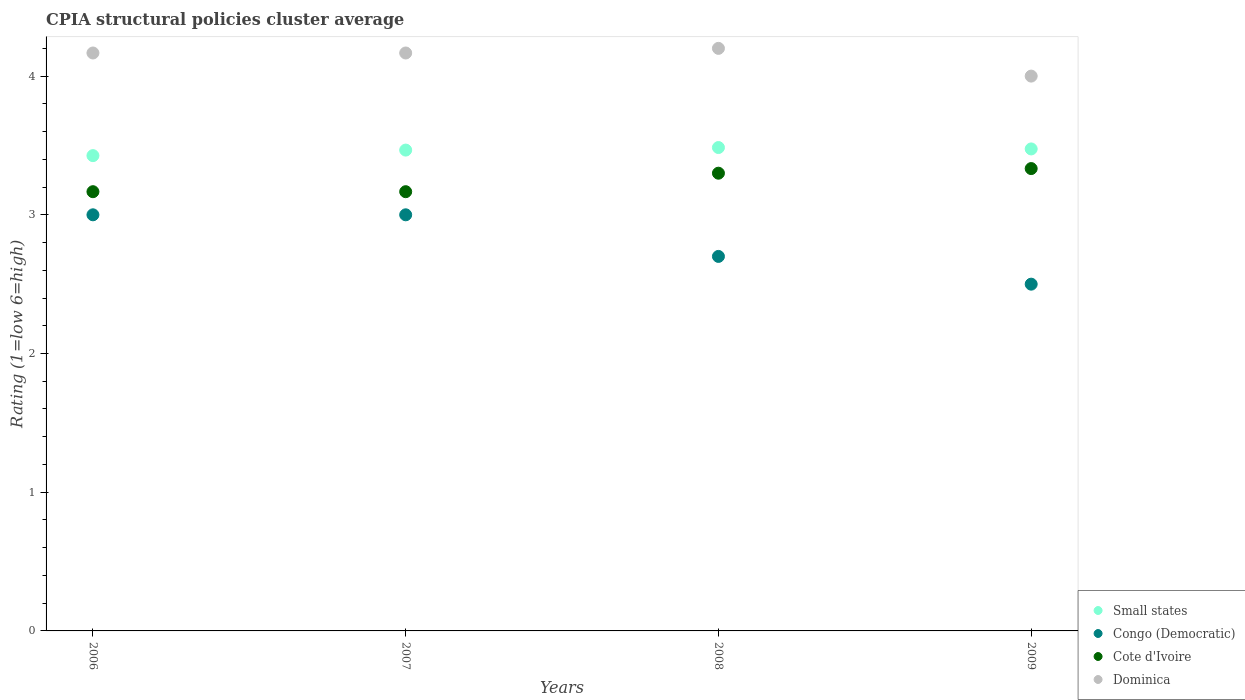How many different coloured dotlines are there?
Provide a succinct answer. 4. What is the CPIA rating in Small states in 2008?
Offer a terse response. 3.48. In which year was the CPIA rating in Dominica maximum?
Provide a short and direct response. 2008. In which year was the CPIA rating in Congo (Democratic) minimum?
Keep it short and to the point. 2009. What is the difference between the CPIA rating in Small states in 2006 and the CPIA rating in Dominica in 2008?
Provide a succinct answer. -0.77. What is the average CPIA rating in Small states per year?
Ensure brevity in your answer.  3.46. In the year 2006, what is the difference between the CPIA rating in Cote d'Ivoire and CPIA rating in Small states?
Keep it short and to the point. -0.26. What is the difference between the highest and the second highest CPIA rating in Congo (Democratic)?
Your answer should be very brief. 0. What is the difference between the highest and the lowest CPIA rating in Dominica?
Your response must be concise. 0.2. Is the sum of the CPIA rating in Cote d'Ivoire in 2006 and 2009 greater than the maximum CPIA rating in Congo (Democratic) across all years?
Provide a short and direct response. Yes. Is it the case that in every year, the sum of the CPIA rating in Small states and CPIA rating in Cote d'Ivoire  is greater than the sum of CPIA rating in Dominica and CPIA rating in Congo (Democratic)?
Your answer should be very brief. No. Is it the case that in every year, the sum of the CPIA rating in Congo (Democratic) and CPIA rating in Small states  is greater than the CPIA rating in Dominica?
Provide a succinct answer. Yes. Does the CPIA rating in Cote d'Ivoire monotonically increase over the years?
Provide a short and direct response. No. Is the CPIA rating in Congo (Democratic) strictly greater than the CPIA rating in Small states over the years?
Offer a terse response. No. Are the values on the major ticks of Y-axis written in scientific E-notation?
Make the answer very short. No. Does the graph contain any zero values?
Your answer should be very brief. No. How many legend labels are there?
Your answer should be very brief. 4. What is the title of the graph?
Offer a terse response. CPIA structural policies cluster average. Does "Hungary" appear as one of the legend labels in the graph?
Make the answer very short. No. What is the label or title of the Y-axis?
Provide a short and direct response. Rating (1=low 6=high). What is the Rating (1=low 6=high) of Small states in 2006?
Provide a short and direct response. 3.43. What is the Rating (1=low 6=high) of Cote d'Ivoire in 2006?
Your answer should be compact. 3.17. What is the Rating (1=low 6=high) in Dominica in 2006?
Offer a very short reply. 4.17. What is the Rating (1=low 6=high) of Small states in 2007?
Your answer should be very brief. 3.47. What is the Rating (1=low 6=high) of Cote d'Ivoire in 2007?
Provide a short and direct response. 3.17. What is the Rating (1=low 6=high) of Dominica in 2007?
Give a very brief answer. 4.17. What is the Rating (1=low 6=high) in Small states in 2008?
Make the answer very short. 3.48. What is the Rating (1=low 6=high) in Cote d'Ivoire in 2008?
Your response must be concise. 3.3. What is the Rating (1=low 6=high) of Small states in 2009?
Provide a short and direct response. 3.48. What is the Rating (1=low 6=high) of Cote d'Ivoire in 2009?
Your answer should be compact. 3.33. What is the Rating (1=low 6=high) of Dominica in 2009?
Ensure brevity in your answer.  4. Across all years, what is the maximum Rating (1=low 6=high) in Small states?
Keep it short and to the point. 3.48. Across all years, what is the maximum Rating (1=low 6=high) of Cote d'Ivoire?
Give a very brief answer. 3.33. Across all years, what is the minimum Rating (1=low 6=high) of Small states?
Give a very brief answer. 3.43. Across all years, what is the minimum Rating (1=low 6=high) in Cote d'Ivoire?
Offer a terse response. 3.17. What is the total Rating (1=low 6=high) of Small states in the graph?
Provide a succinct answer. 13.85. What is the total Rating (1=low 6=high) of Congo (Democratic) in the graph?
Offer a very short reply. 11.2. What is the total Rating (1=low 6=high) of Cote d'Ivoire in the graph?
Keep it short and to the point. 12.97. What is the total Rating (1=low 6=high) in Dominica in the graph?
Provide a succinct answer. 16.53. What is the difference between the Rating (1=low 6=high) in Small states in 2006 and that in 2007?
Your answer should be compact. -0.04. What is the difference between the Rating (1=low 6=high) in Cote d'Ivoire in 2006 and that in 2007?
Your answer should be compact. 0. What is the difference between the Rating (1=low 6=high) of Dominica in 2006 and that in 2007?
Your answer should be compact. 0. What is the difference between the Rating (1=low 6=high) in Small states in 2006 and that in 2008?
Offer a very short reply. -0.06. What is the difference between the Rating (1=low 6=high) in Congo (Democratic) in 2006 and that in 2008?
Your response must be concise. 0.3. What is the difference between the Rating (1=low 6=high) of Cote d'Ivoire in 2006 and that in 2008?
Ensure brevity in your answer.  -0.13. What is the difference between the Rating (1=low 6=high) of Dominica in 2006 and that in 2008?
Offer a very short reply. -0.03. What is the difference between the Rating (1=low 6=high) in Small states in 2006 and that in 2009?
Your answer should be very brief. -0.05. What is the difference between the Rating (1=low 6=high) of Small states in 2007 and that in 2008?
Your answer should be very brief. -0.02. What is the difference between the Rating (1=low 6=high) of Congo (Democratic) in 2007 and that in 2008?
Make the answer very short. 0.3. What is the difference between the Rating (1=low 6=high) in Cote d'Ivoire in 2007 and that in 2008?
Offer a very short reply. -0.13. What is the difference between the Rating (1=low 6=high) of Dominica in 2007 and that in 2008?
Give a very brief answer. -0.03. What is the difference between the Rating (1=low 6=high) in Small states in 2007 and that in 2009?
Offer a terse response. -0.01. What is the difference between the Rating (1=low 6=high) in Congo (Democratic) in 2007 and that in 2009?
Your response must be concise. 0.5. What is the difference between the Rating (1=low 6=high) of Congo (Democratic) in 2008 and that in 2009?
Offer a terse response. 0.2. What is the difference between the Rating (1=low 6=high) of Cote d'Ivoire in 2008 and that in 2009?
Offer a very short reply. -0.03. What is the difference between the Rating (1=low 6=high) in Small states in 2006 and the Rating (1=low 6=high) in Congo (Democratic) in 2007?
Make the answer very short. 0.43. What is the difference between the Rating (1=low 6=high) in Small states in 2006 and the Rating (1=low 6=high) in Cote d'Ivoire in 2007?
Give a very brief answer. 0.26. What is the difference between the Rating (1=low 6=high) in Small states in 2006 and the Rating (1=low 6=high) in Dominica in 2007?
Offer a very short reply. -0.74. What is the difference between the Rating (1=low 6=high) of Congo (Democratic) in 2006 and the Rating (1=low 6=high) of Cote d'Ivoire in 2007?
Offer a very short reply. -0.17. What is the difference between the Rating (1=low 6=high) in Congo (Democratic) in 2006 and the Rating (1=low 6=high) in Dominica in 2007?
Offer a very short reply. -1.17. What is the difference between the Rating (1=low 6=high) of Cote d'Ivoire in 2006 and the Rating (1=low 6=high) of Dominica in 2007?
Offer a very short reply. -1. What is the difference between the Rating (1=low 6=high) of Small states in 2006 and the Rating (1=low 6=high) of Congo (Democratic) in 2008?
Your answer should be very brief. 0.73. What is the difference between the Rating (1=low 6=high) of Small states in 2006 and the Rating (1=low 6=high) of Cote d'Ivoire in 2008?
Give a very brief answer. 0.13. What is the difference between the Rating (1=low 6=high) in Small states in 2006 and the Rating (1=low 6=high) in Dominica in 2008?
Ensure brevity in your answer.  -0.77. What is the difference between the Rating (1=low 6=high) of Congo (Democratic) in 2006 and the Rating (1=low 6=high) of Dominica in 2008?
Your answer should be compact. -1.2. What is the difference between the Rating (1=low 6=high) of Cote d'Ivoire in 2006 and the Rating (1=low 6=high) of Dominica in 2008?
Your answer should be very brief. -1.03. What is the difference between the Rating (1=low 6=high) in Small states in 2006 and the Rating (1=low 6=high) in Congo (Democratic) in 2009?
Your answer should be very brief. 0.93. What is the difference between the Rating (1=low 6=high) of Small states in 2006 and the Rating (1=low 6=high) of Cote d'Ivoire in 2009?
Give a very brief answer. 0.09. What is the difference between the Rating (1=low 6=high) of Small states in 2006 and the Rating (1=low 6=high) of Dominica in 2009?
Keep it short and to the point. -0.57. What is the difference between the Rating (1=low 6=high) of Congo (Democratic) in 2006 and the Rating (1=low 6=high) of Dominica in 2009?
Provide a short and direct response. -1. What is the difference between the Rating (1=low 6=high) in Small states in 2007 and the Rating (1=low 6=high) in Congo (Democratic) in 2008?
Make the answer very short. 0.77. What is the difference between the Rating (1=low 6=high) of Small states in 2007 and the Rating (1=low 6=high) of Cote d'Ivoire in 2008?
Provide a succinct answer. 0.17. What is the difference between the Rating (1=low 6=high) of Small states in 2007 and the Rating (1=low 6=high) of Dominica in 2008?
Make the answer very short. -0.73. What is the difference between the Rating (1=low 6=high) in Congo (Democratic) in 2007 and the Rating (1=low 6=high) in Cote d'Ivoire in 2008?
Keep it short and to the point. -0.3. What is the difference between the Rating (1=low 6=high) in Congo (Democratic) in 2007 and the Rating (1=low 6=high) in Dominica in 2008?
Give a very brief answer. -1.2. What is the difference between the Rating (1=low 6=high) in Cote d'Ivoire in 2007 and the Rating (1=low 6=high) in Dominica in 2008?
Keep it short and to the point. -1.03. What is the difference between the Rating (1=low 6=high) of Small states in 2007 and the Rating (1=low 6=high) of Congo (Democratic) in 2009?
Offer a terse response. 0.97. What is the difference between the Rating (1=low 6=high) of Small states in 2007 and the Rating (1=low 6=high) of Cote d'Ivoire in 2009?
Keep it short and to the point. 0.13. What is the difference between the Rating (1=low 6=high) of Small states in 2007 and the Rating (1=low 6=high) of Dominica in 2009?
Give a very brief answer. -0.53. What is the difference between the Rating (1=low 6=high) of Small states in 2008 and the Rating (1=low 6=high) of Cote d'Ivoire in 2009?
Your answer should be compact. 0.15. What is the difference between the Rating (1=low 6=high) in Small states in 2008 and the Rating (1=low 6=high) in Dominica in 2009?
Your answer should be very brief. -0.52. What is the difference between the Rating (1=low 6=high) in Congo (Democratic) in 2008 and the Rating (1=low 6=high) in Cote d'Ivoire in 2009?
Keep it short and to the point. -0.63. What is the average Rating (1=low 6=high) of Small states per year?
Provide a succinct answer. 3.46. What is the average Rating (1=low 6=high) in Congo (Democratic) per year?
Your response must be concise. 2.8. What is the average Rating (1=low 6=high) of Cote d'Ivoire per year?
Make the answer very short. 3.24. What is the average Rating (1=low 6=high) in Dominica per year?
Offer a very short reply. 4.13. In the year 2006, what is the difference between the Rating (1=low 6=high) of Small states and Rating (1=low 6=high) of Congo (Democratic)?
Offer a terse response. 0.43. In the year 2006, what is the difference between the Rating (1=low 6=high) in Small states and Rating (1=low 6=high) in Cote d'Ivoire?
Provide a short and direct response. 0.26. In the year 2006, what is the difference between the Rating (1=low 6=high) in Small states and Rating (1=low 6=high) in Dominica?
Provide a short and direct response. -0.74. In the year 2006, what is the difference between the Rating (1=low 6=high) in Congo (Democratic) and Rating (1=low 6=high) in Dominica?
Give a very brief answer. -1.17. In the year 2006, what is the difference between the Rating (1=low 6=high) in Cote d'Ivoire and Rating (1=low 6=high) in Dominica?
Give a very brief answer. -1. In the year 2007, what is the difference between the Rating (1=low 6=high) in Small states and Rating (1=low 6=high) in Congo (Democratic)?
Make the answer very short. 0.47. In the year 2007, what is the difference between the Rating (1=low 6=high) in Small states and Rating (1=low 6=high) in Cote d'Ivoire?
Ensure brevity in your answer.  0.3. In the year 2007, what is the difference between the Rating (1=low 6=high) of Small states and Rating (1=low 6=high) of Dominica?
Keep it short and to the point. -0.7. In the year 2007, what is the difference between the Rating (1=low 6=high) in Congo (Democratic) and Rating (1=low 6=high) in Dominica?
Your answer should be very brief. -1.17. In the year 2008, what is the difference between the Rating (1=low 6=high) in Small states and Rating (1=low 6=high) in Congo (Democratic)?
Your answer should be compact. 0.79. In the year 2008, what is the difference between the Rating (1=low 6=high) in Small states and Rating (1=low 6=high) in Cote d'Ivoire?
Your answer should be very brief. 0.18. In the year 2008, what is the difference between the Rating (1=low 6=high) in Small states and Rating (1=low 6=high) in Dominica?
Your answer should be very brief. -0.71. In the year 2008, what is the difference between the Rating (1=low 6=high) in Congo (Democratic) and Rating (1=low 6=high) in Cote d'Ivoire?
Keep it short and to the point. -0.6. In the year 2008, what is the difference between the Rating (1=low 6=high) of Congo (Democratic) and Rating (1=low 6=high) of Dominica?
Give a very brief answer. -1.5. In the year 2009, what is the difference between the Rating (1=low 6=high) in Small states and Rating (1=low 6=high) in Cote d'Ivoire?
Your response must be concise. 0.14. In the year 2009, what is the difference between the Rating (1=low 6=high) of Small states and Rating (1=low 6=high) of Dominica?
Give a very brief answer. -0.53. What is the ratio of the Rating (1=low 6=high) of Small states in 2006 to that in 2008?
Ensure brevity in your answer.  0.98. What is the ratio of the Rating (1=low 6=high) of Cote d'Ivoire in 2006 to that in 2008?
Your response must be concise. 0.96. What is the ratio of the Rating (1=low 6=high) in Small states in 2006 to that in 2009?
Your answer should be very brief. 0.99. What is the ratio of the Rating (1=low 6=high) in Dominica in 2006 to that in 2009?
Offer a very short reply. 1.04. What is the ratio of the Rating (1=low 6=high) of Congo (Democratic) in 2007 to that in 2008?
Your response must be concise. 1.11. What is the ratio of the Rating (1=low 6=high) in Cote d'Ivoire in 2007 to that in 2008?
Offer a terse response. 0.96. What is the ratio of the Rating (1=low 6=high) of Dominica in 2007 to that in 2008?
Give a very brief answer. 0.99. What is the ratio of the Rating (1=low 6=high) in Small states in 2007 to that in 2009?
Provide a succinct answer. 1. What is the ratio of the Rating (1=low 6=high) in Cote d'Ivoire in 2007 to that in 2009?
Ensure brevity in your answer.  0.95. What is the ratio of the Rating (1=low 6=high) of Dominica in 2007 to that in 2009?
Offer a terse response. 1.04. What is the ratio of the Rating (1=low 6=high) of Small states in 2008 to that in 2009?
Keep it short and to the point. 1. What is the ratio of the Rating (1=low 6=high) of Congo (Democratic) in 2008 to that in 2009?
Make the answer very short. 1.08. What is the ratio of the Rating (1=low 6=high) in Cote d'Ivoire in 2008 to that in 2009?
Provide a short and direct response. 0.99. What is the ratio of the Rating (1=low 6=high) in Dominica in 2008 to that in 2009?
Offer a very short reply. 1.05. What is the difference between the highest and the second highest Rating (1=low 6=high) in Small states?
Your answer should be very brief. 0.01. What is the difference between the highest and the second highest Rating (1=low 6=high) of Congo (Democratic)?
Provide a succinct answer. 0. What is the difference between the highest and the lowest Rating (1=low 6=high) of Small states?
Offer a very short reply. 0.06. What is the difference between the highest and the lowest Rating (1=low 6=high) of Cote d'Ivoire?
Keep it short and to the point. 0.17. 